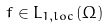Convert formula to latex. <formula><loc_0><loc_0><loc_500><loc_500>f \in L _ { 1 , l o c } ( \Omega )</formula> 